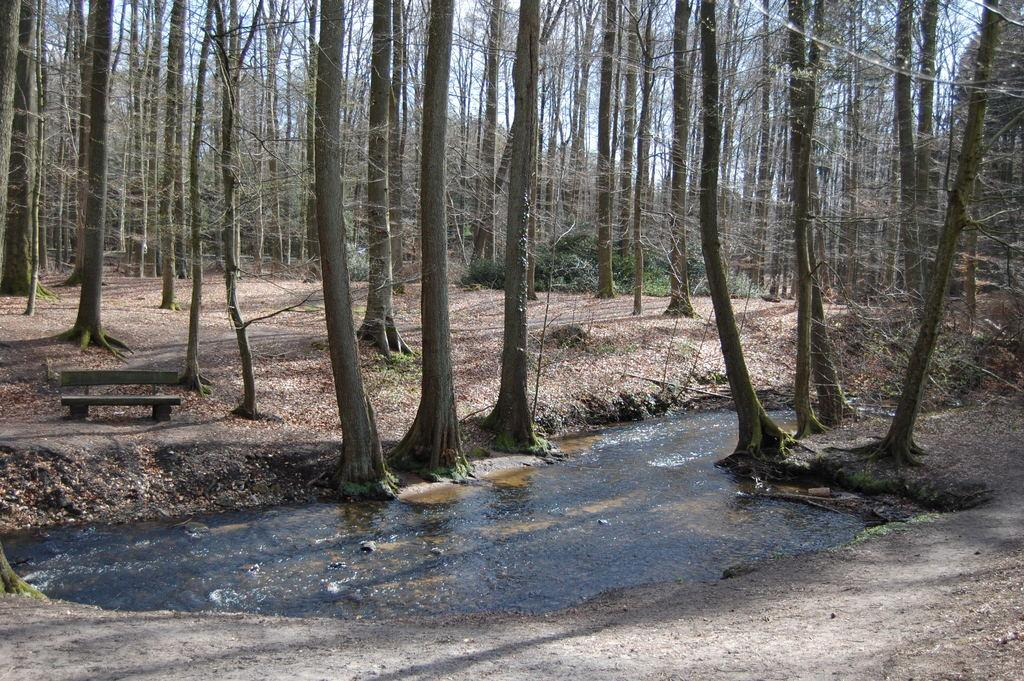What is located on the ground in the image? There is a bench on the ground in the image. What can be seen in the image besides the bench? There is water visible in the image, as well as trees. What is visible in the background of the image? The sky is visible in the background of the image. Can you tell me how many friends and pets are visible in the image? There are no friends or pets present in the image; it features a bench, water, trees, and the sky. Is there an army visible in the image? There is no army present in the image. 